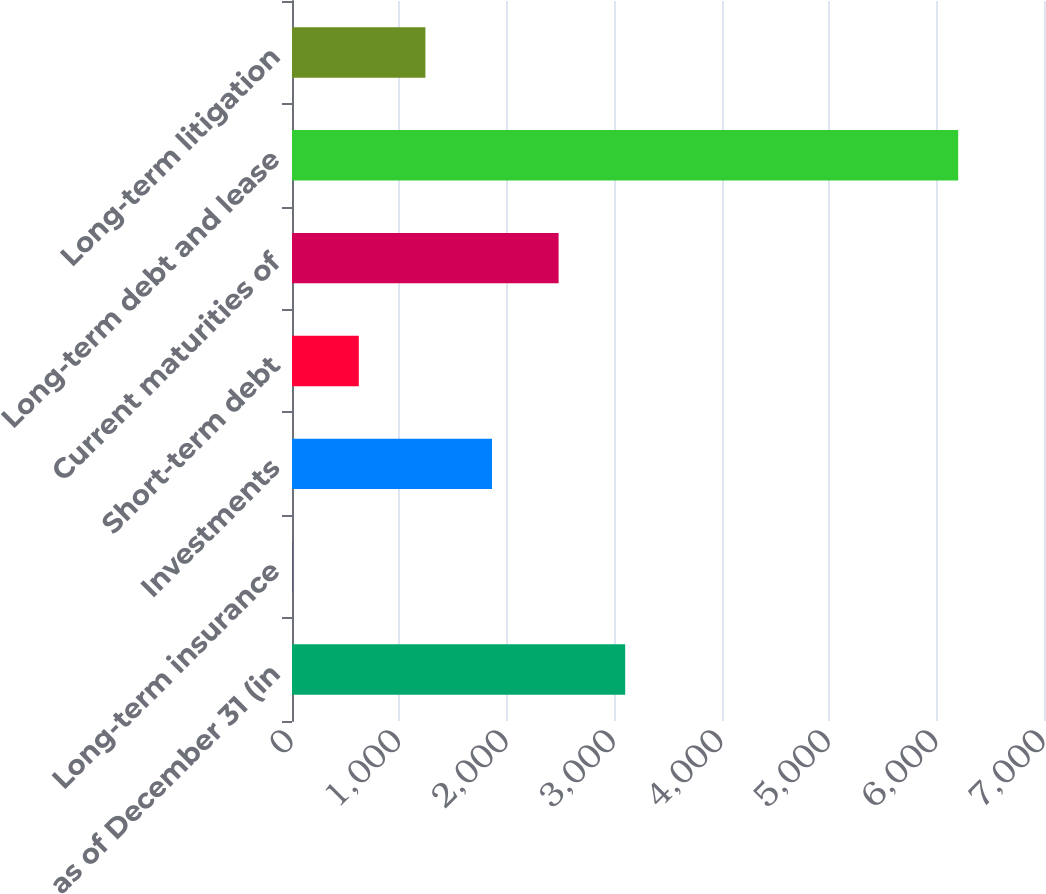Convert chart. <chart><loc_0><loc_0><loc_500><loc_500><bar_chart><fcel>as of December 31 (in<fcel>Long-term insurance<fcel>Investments<fcel>Short-term debt<fcel>Current maturities of<fcel>Long-term debt and lease<fcel>Long-term litigation<nl><fcel>3101.5<fcel>2<fcel>1861.7<fcel>621.9<fcel>2481.6<fcel>6201<fcel>1241.8<nl></chart> 